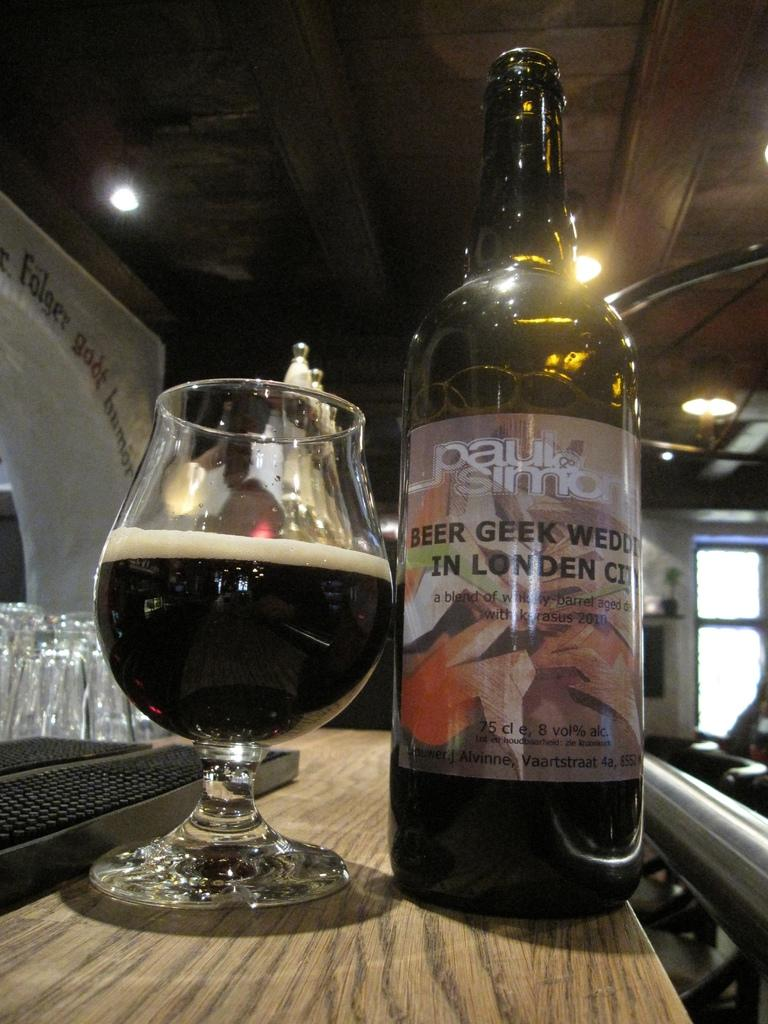What is the main piece of furniture in the image? There is a table in the image. What is placed on the table? There is a bottle and a glass with a drink in it on the table. What can be seen in the background of the image? There is a window, a light, text, and a wall in the background of the image. How does the lettuce support the steam in the image? There is no lettuce or steam present in the image. 